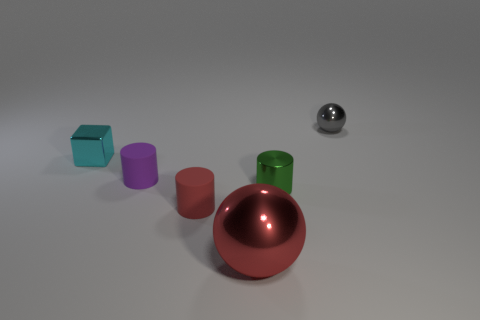There is a shiny thing that is behind the small green metallic cylinder and left of the tiny gray object; what color is it?
Provide a succinct answer. Cyan. How many cyan metallic things are the same size as the purple thing?
Keep it short and to the point. 1. There is a small thing that is to the right of the small cylinder right of the tiny red cylinder; what is its shape?
Your answer should be compact. Sphere. There is a small metallic object on the left side of the ball in front of the gray sphere on the right side of the cyan metallic block; what shape is it?
Your answer should be compact. Cube. What number of other tiny shiny objects are the same shape as the red metal thing?
Provide a short and direct response. 1. There is a ball behind the green cylinder; how many green metallic cylinders are behind it?
Offer a terse response. 0. What number of shiny things are either large red spheres or large green cylinders?
Provide a succinct answer. 1. Are there any red objects that have the same material as the small green cylinder?
Offer a very short reply. Yes. What number of things are either metal balls behind the large red thing or metal spheres that are behind the small shiny cube?
Provide a short and direct response. 1. There is a matte cylinder right of the tiny purple object; does it have the same color as the big shiny thing?
Keep it short and to the point. Yes. 